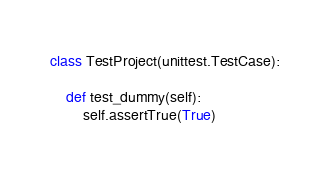<code> <loc_0><loc_0><loc_500><loc_500><_Python_>class TestProject(unittest.TestCase):

    def test_dummy(self):
        self.assertTrue(True)</code> 